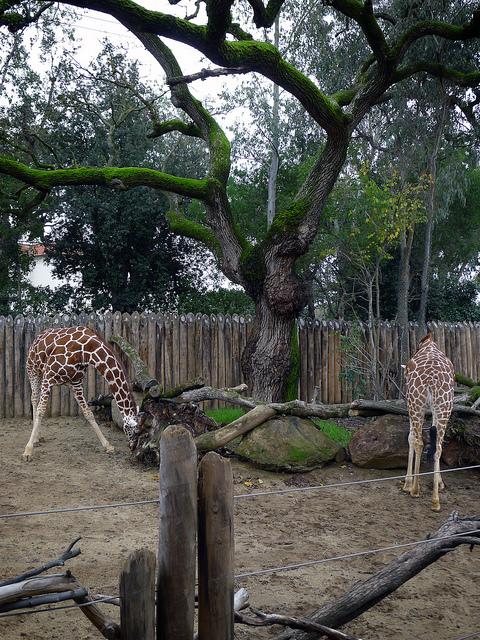Are the giraffe's approximately the same size?
Quick response, please. Yes. What is the wall made of?
Keep it brief. Wood. If the Giraffes extended their necks, would they be able to reach a branch on the tree pictured?
Keep it brief. Yes. Could this photo be from a zoo?
Keep it brief. Yes. 